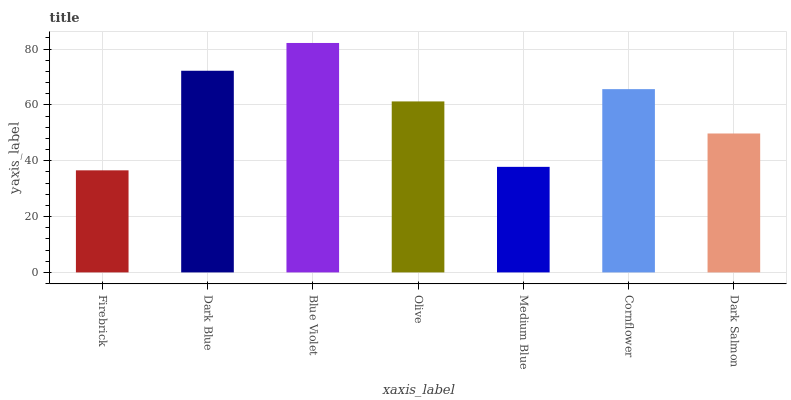Is Dark Blue the minimum?
Answer yes or no. No. Is Dark Blue the maximum?
Answer yes or no. No. Is Dark Blue greater than Firebrick?
Answer yes or no. Yes. Is Firebrick less than Dark Blue?
Answer yes or no. Yes. Is Firebrick greater than Dark Blue?
Answer yes or no. No. Is Dark Blue less than Firebrick?
Answer yes or no. No. Is Olive the high median?
Answer yes or no. Yes. Is Olive the low median?
Answer yes or no. Yes. Is Dark Blue the high median?
Answer yes or no. No. Is Blue Violet the low median?
Answer yes or no. No. 